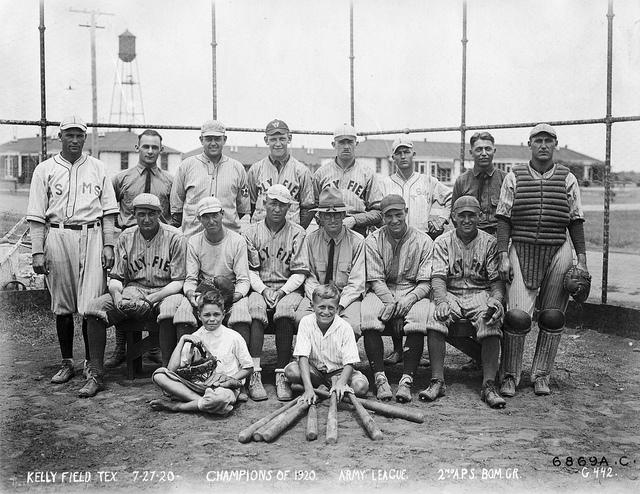What role does the most heavily armored person shown here hold?

Choices:
A) runner
B) pitcher
C) catcher
D) batter catcher 